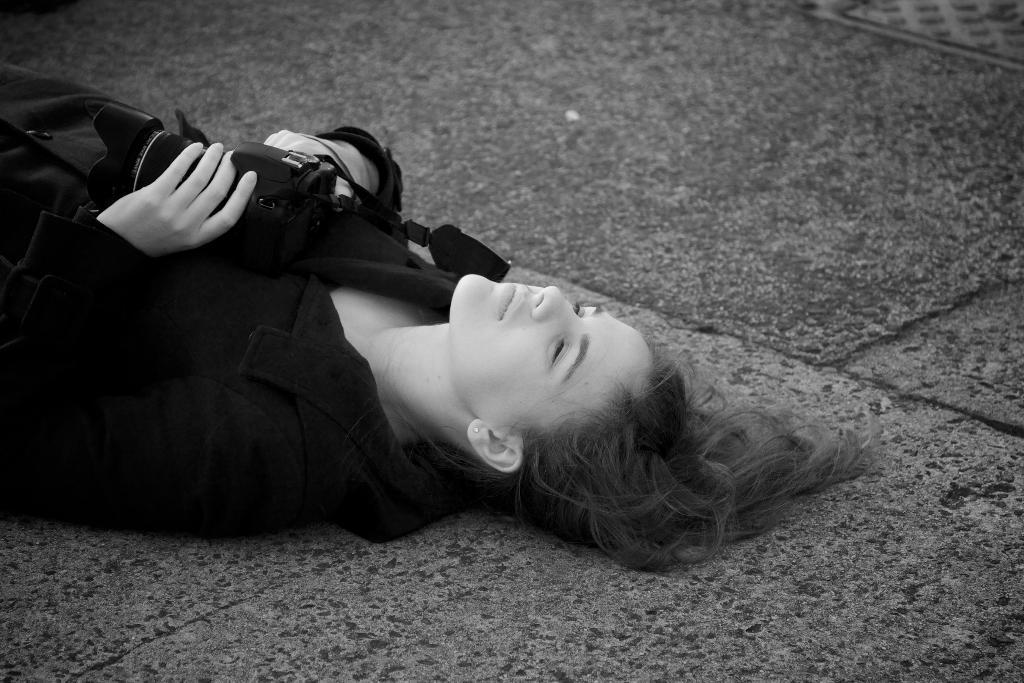Who is the main subject in the image? There is a woman in the image. What is the woman doing in the image? The woman is lying on the floor. What object is the woman holding in the image? The woman is holding a camera. What type of monkey can be seen climbing the mailbox in the image? There is no monkey or mailbox present in the image. Can you describe the window in the image? There is no window present in the image. 